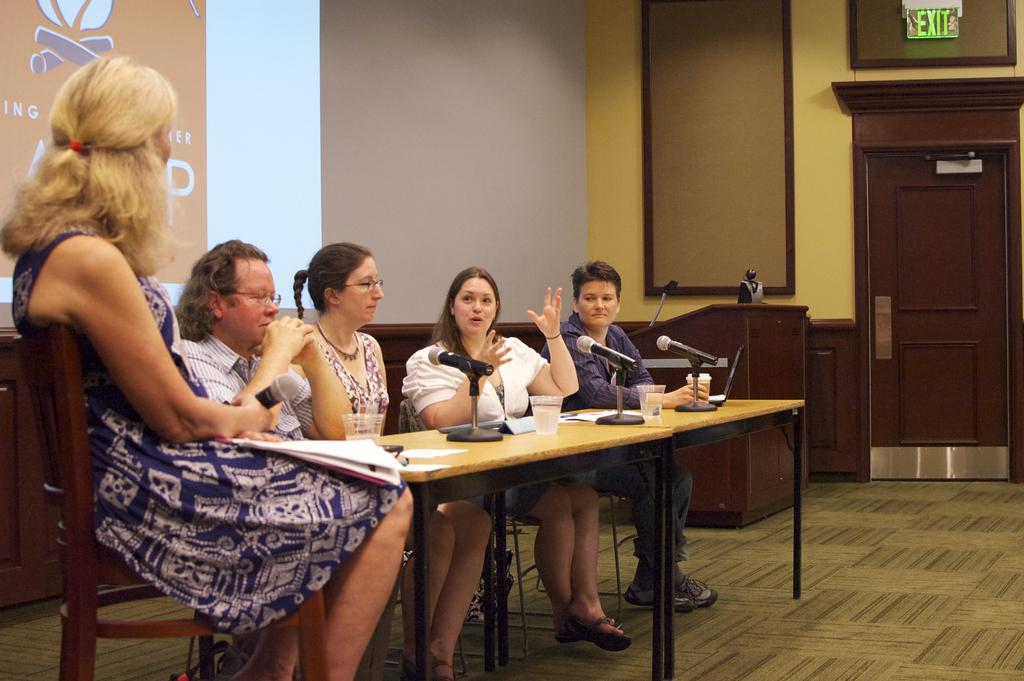What are the people in the image doing? There is a group of people sitting on chairs in the image. What is in front of the chairs? There is a table in front of the chairs. What is on the table? There is a microphone and papers on the table. What can be seen at the back of the scene? There is a wall at the back of the scene. Is there any entrance or exit in the scene? Yes, there is a door in the scene. Can you see a rifle on the table in the image? No, there is no rifle present on the table in the image. 